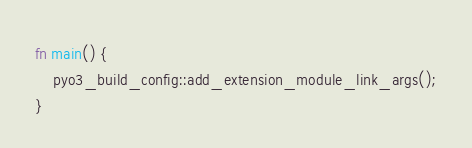Convert code to text. <code><loc_0><loc_0><loc_500><loc_500><_Rust_>fn main() {
    pyo3_build_config::add_extension_module_link_args();
}</code> 